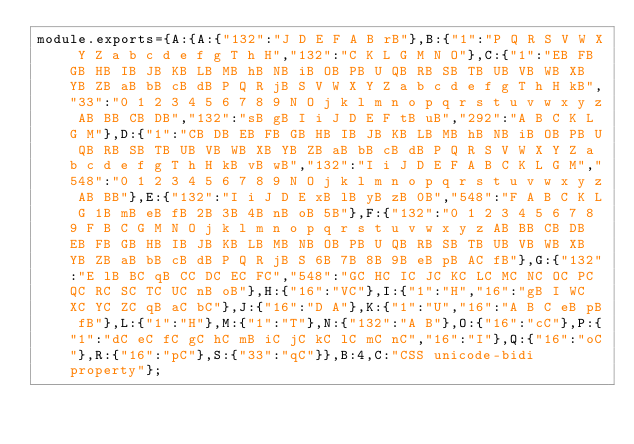<code> <loc_0><loc_0><loc_500><loc_500><_JavaScript_>module.exports={A:{A:{"132":"J D E F A B rB"},B:{"1":"P Q R S V W X Y Z a b c d e f g T h H","132":"C K L G M N O"},C:{"1":"EB FB GB HB IB JB KB LB MB hB NB iB OB PB U QB RB SB TB UB VB WB XB YB ZB aB bB cB dB P Q R jB S V W X Y Z a b c d e f g T h H kB","33":"0 1 2 3 4 5 6 7 8 9 N O j k l m n o p q r s t u v w x y z AB BB CB DB","132":"sB gB I i J D E F tB uB","292":"A B C K L G M"},D:{"1":"CB DB EB FB GB HB IB JB KB LB MB hB NB iB OB PB U QB RB SB TB UB VB WB XB YB ZB aB bB cB dB P Q R S V W X Y Z a b c d e f g T h H kB vB wB","132":"I i J D E F A B C K L G M","548":"0 1 2 3 4 5 6 7 8 9 N O j k l m n o p q r s t u v w x y z AB BB"},E:{"132":"I i J D E xB lB yB zB 0B","548":"F A B C K L G 1B mB eB fB 2B 3B 4B nB oB 5B"},F:{"132":"0 1 2 3 4 5 6 7 8 9 F B C G M N O j k l m n o p q r s t u v w x y z AB BB CB DB EB FB GB HB IB JB KB LB MB NB OB PB U QB RB SB TB UB VB WB XB YB ZB aB bB cB dB P Q R jB S 6B 7B 8B 9B eB pB AC fB"},G:{"132":"E lB BC qB CC DC EC FC","548":"GC HC IC JC KC LC MC NC OC PC QC RC SC TC UC nB oB"},H:{"16":"VC"},I:{"1":"H","16":"gB I WC XC YC ZC qB aC bC"},J:{"16":"D A"},K:{"1":"U","16":"A B C eB pB fB"},L:{"1":"H"},M:{"1":"T"},N:{"132":"A B"},O:{"16":"cC"},P:{"1":"dC eC fC gC hC mB iC jC kC lC mC nC","16":"I"},Q:{"16":"oC"},R:{"16":"pC"},S:{"33":"qC"}},B:4,C:"CSS unicode-bidi property"};
</code> 